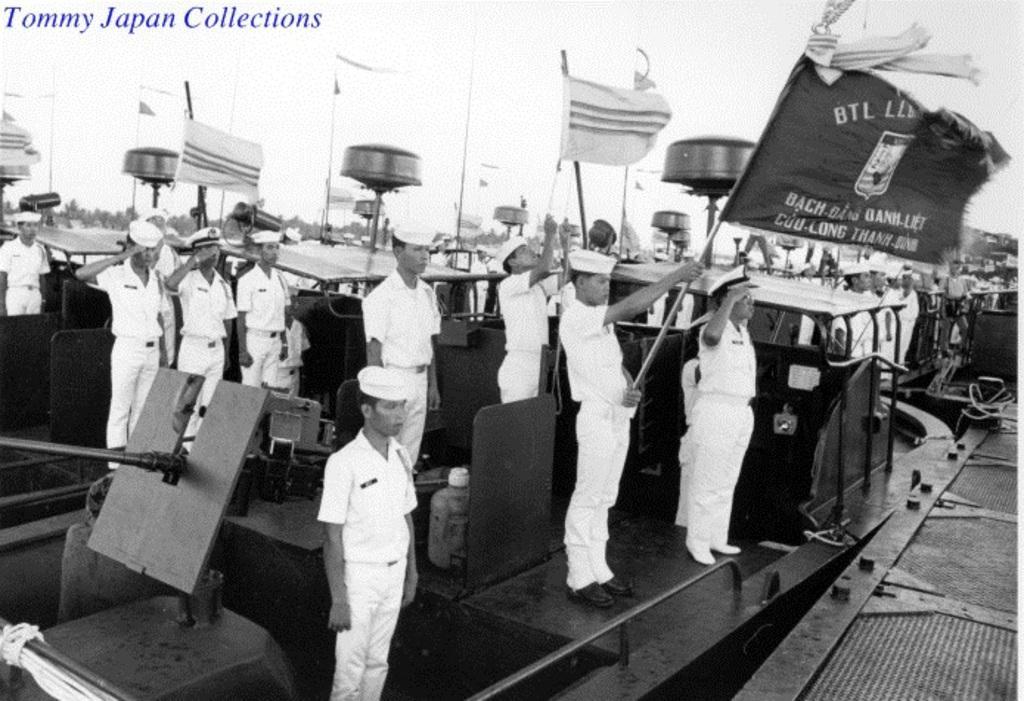Describe this image in one or two sentences. In the picture we can see a black and white photograph on a boat near the path and people on the boat are standing, they are in white uniform with caps and some are holding flags with poles and in the background we can see some poles and sky. 